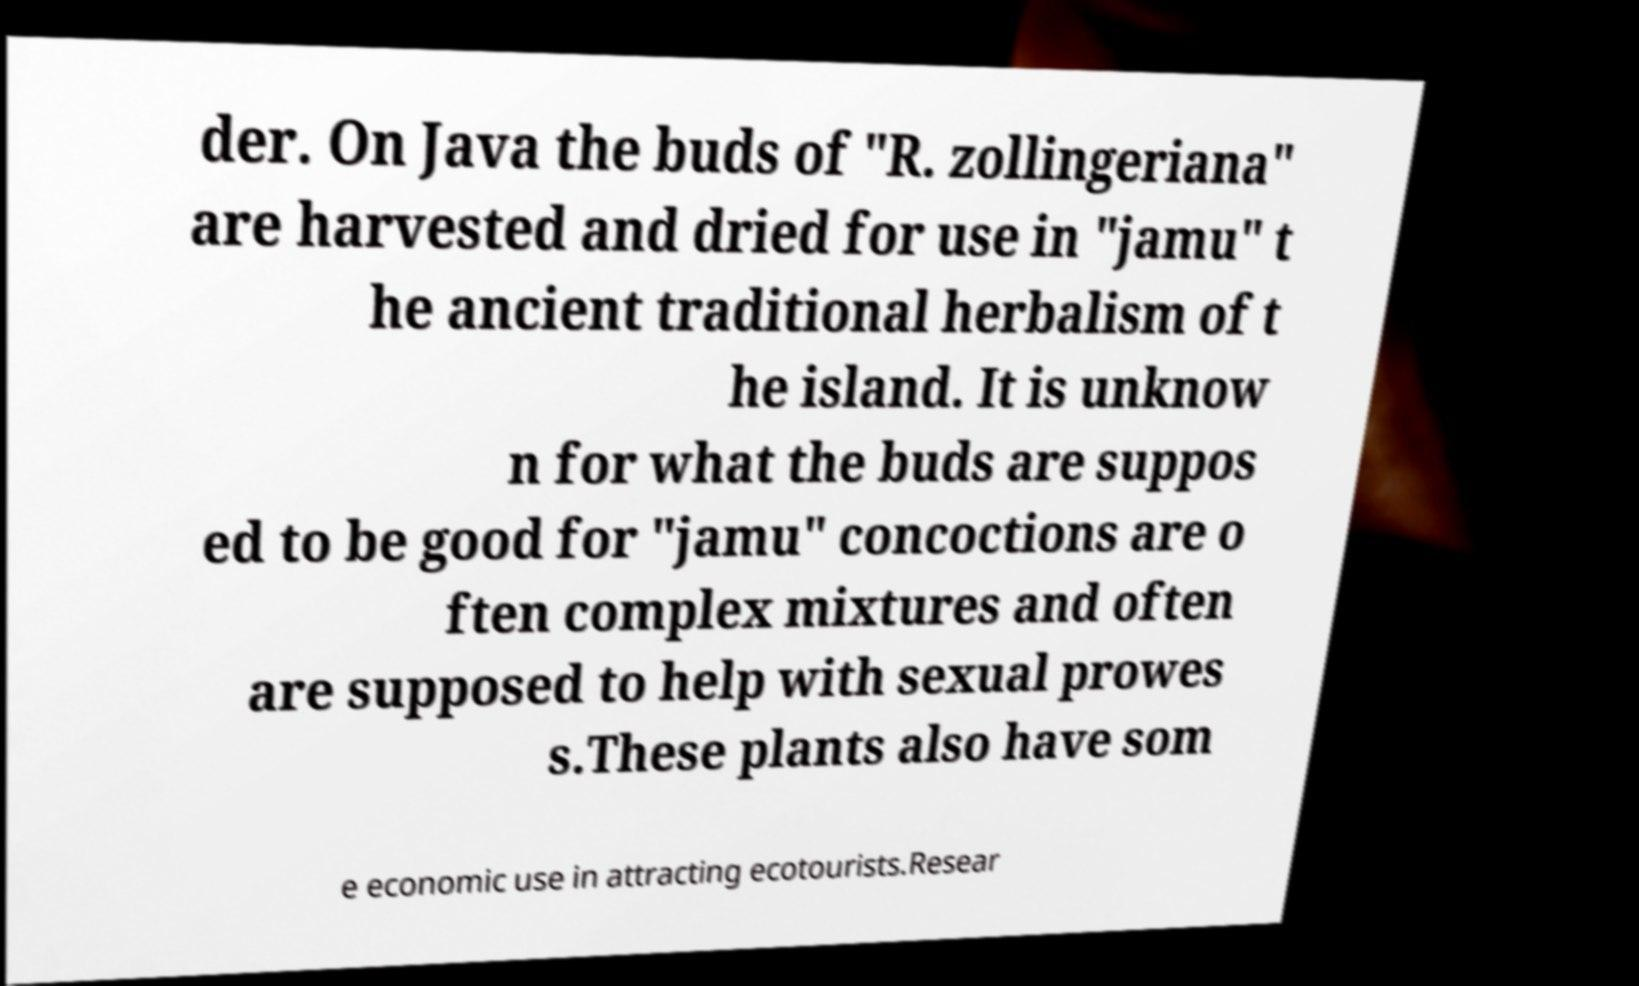Could you extract and type out the text from this image? der. On Java the buds of "R. zollingeriana" are harvested and dried for use in "jamu" t he ancient traditional herbalism of t he island. It is unknow n for what the buds are suppos ed to be good for "jamu" concoctions are o ften complex mixtures and often are supposed to help with sexual prowes s.These plants also have som e economic use in attracting ecotourists.Resear 